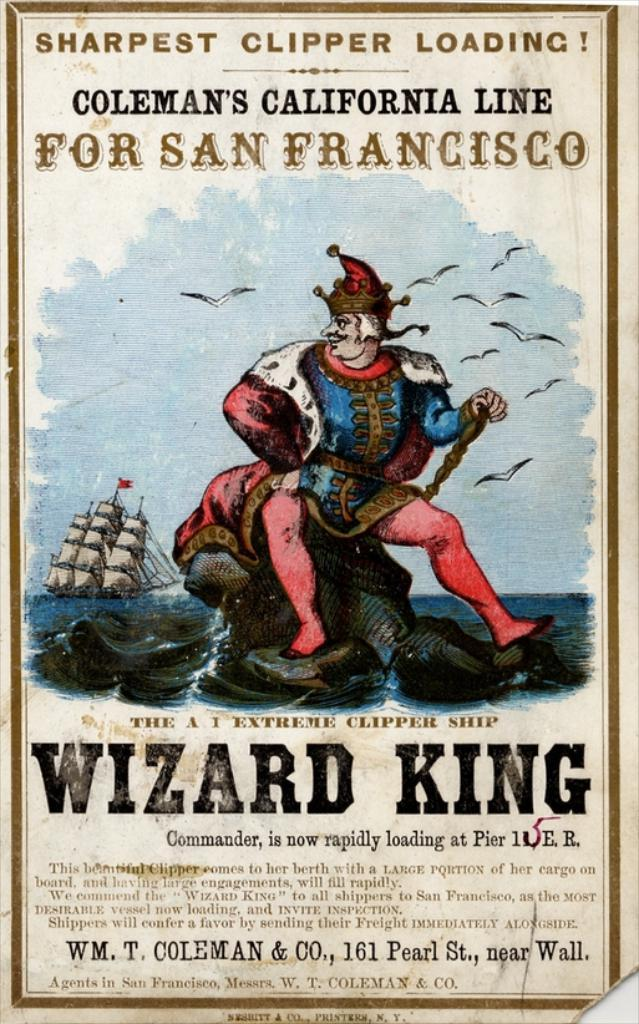<image>
Present a compact description of the photo's key features. A poster for Coleman's California Line for San Francisco. 